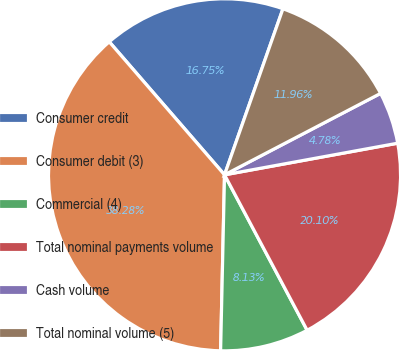Convert chart to OTSL. <chart><loc_0><loc_0><loc_500><loc_500><pie_chart><fcel>Consumer credit<fcel>Consumer debit (3)<fcel>Commercial (4)<fcel>Total nominal payments volume<fcel>Cash volume<fcel>Total nominal volume (5)<nl><fcel>16.75%<fcel>38.28%<fcel>8.13%<fcel>20.1%<fcel>4.78%<fcel>11.96%<nl></chart> 